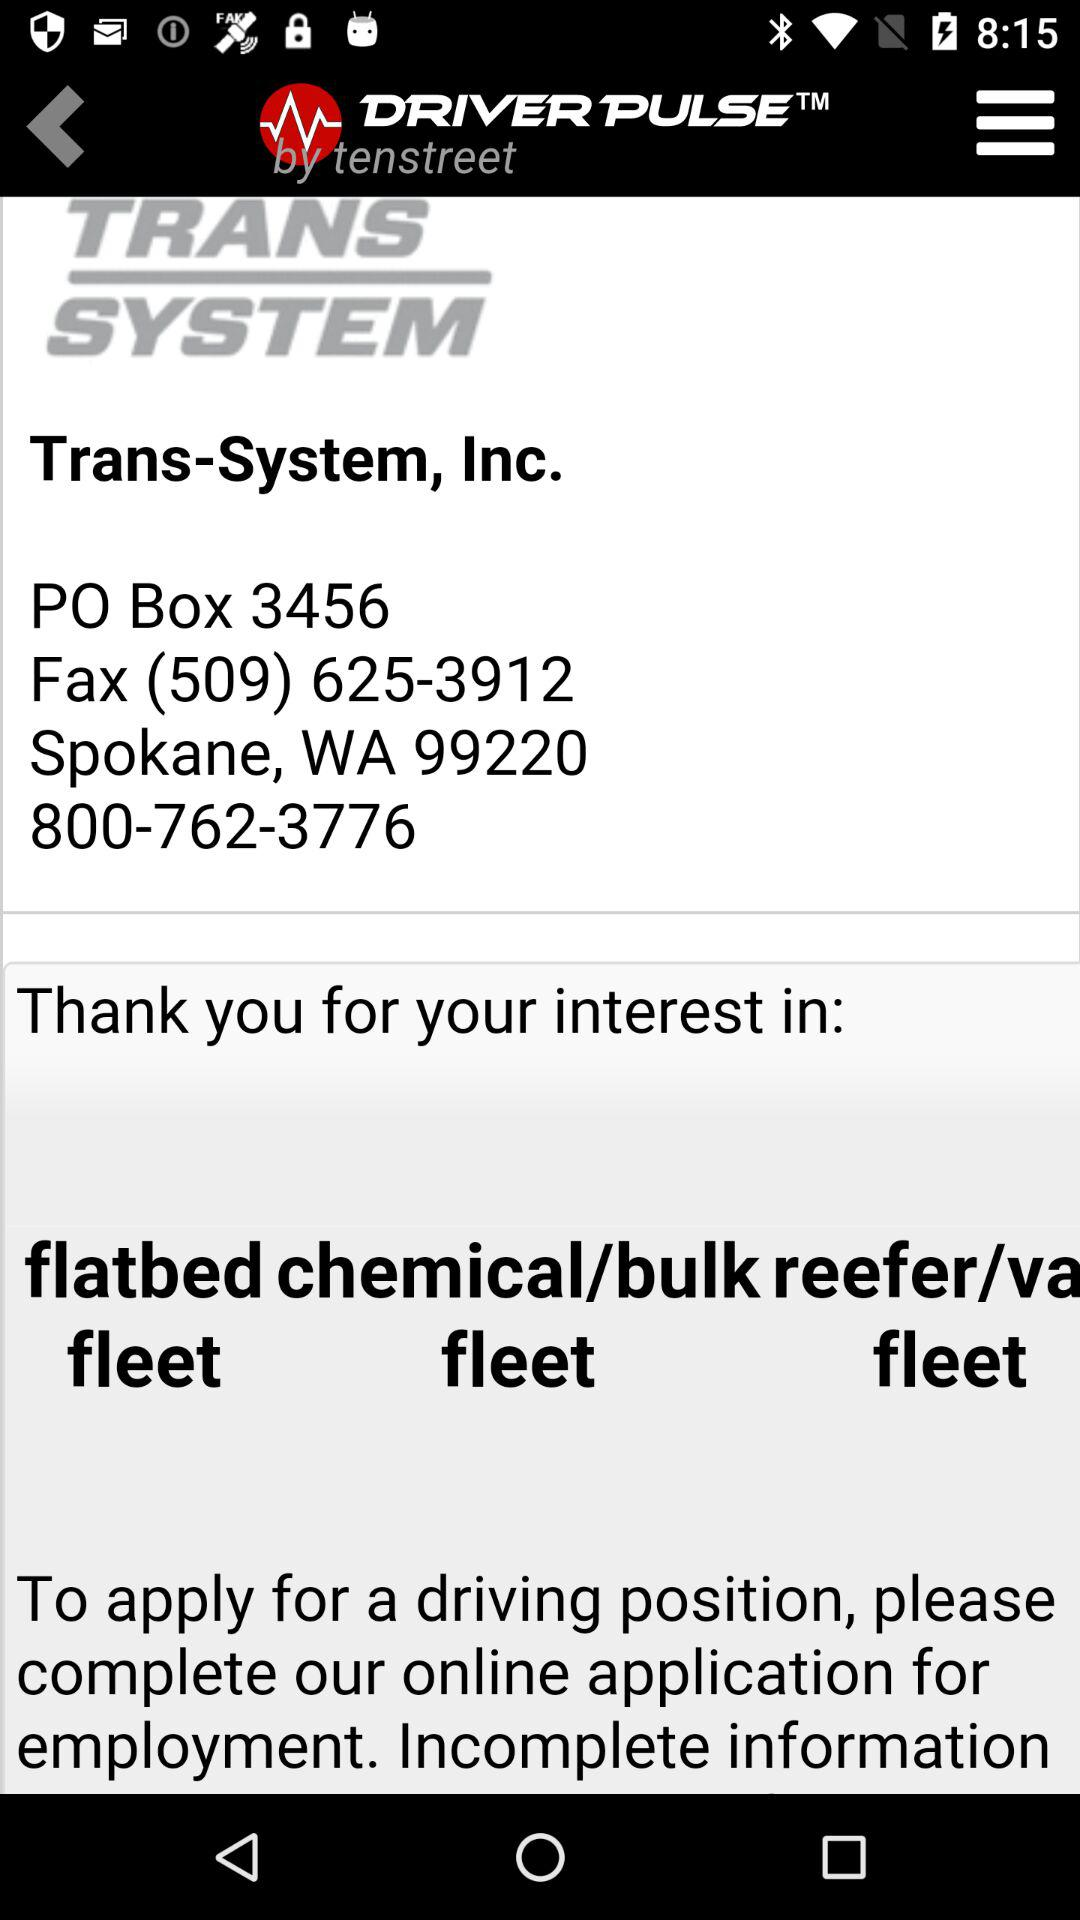What is the given phone number? The given number is 800-762-3776. 